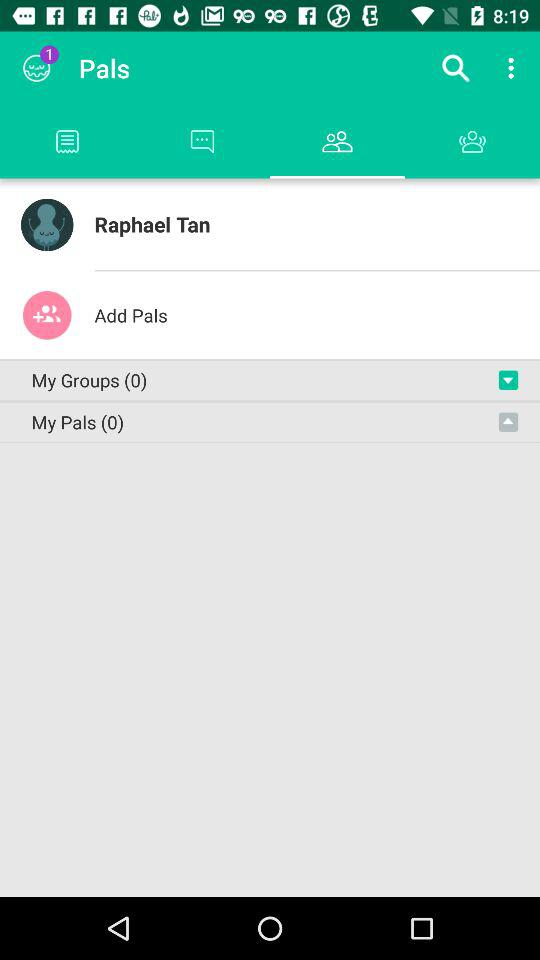How many notifications are there? There is 1 notification. 